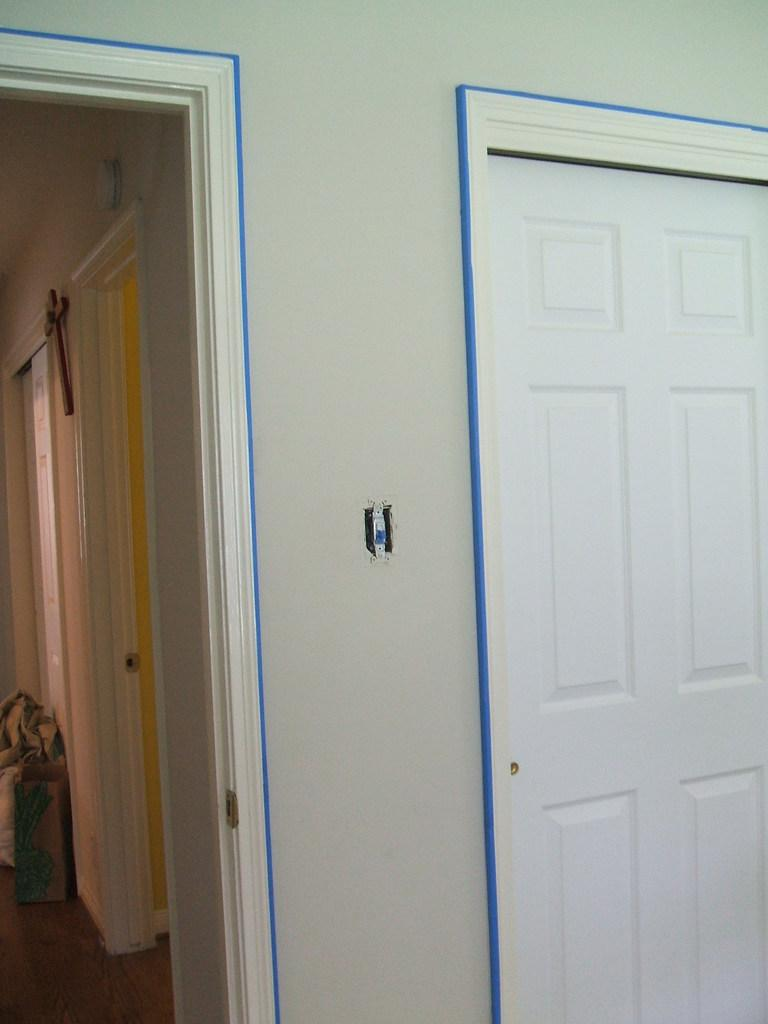What color is the door in the image? The door in the image is white-colored. What can be seen on the wall in the image? There are blue-colored lines on the wall in the image. Where is the faucet located in the image? There is no faucet present in the image. What type of brake is depicted on the wall in the image? There is no brake present in the image; only blue lines can be seen on the wall. 